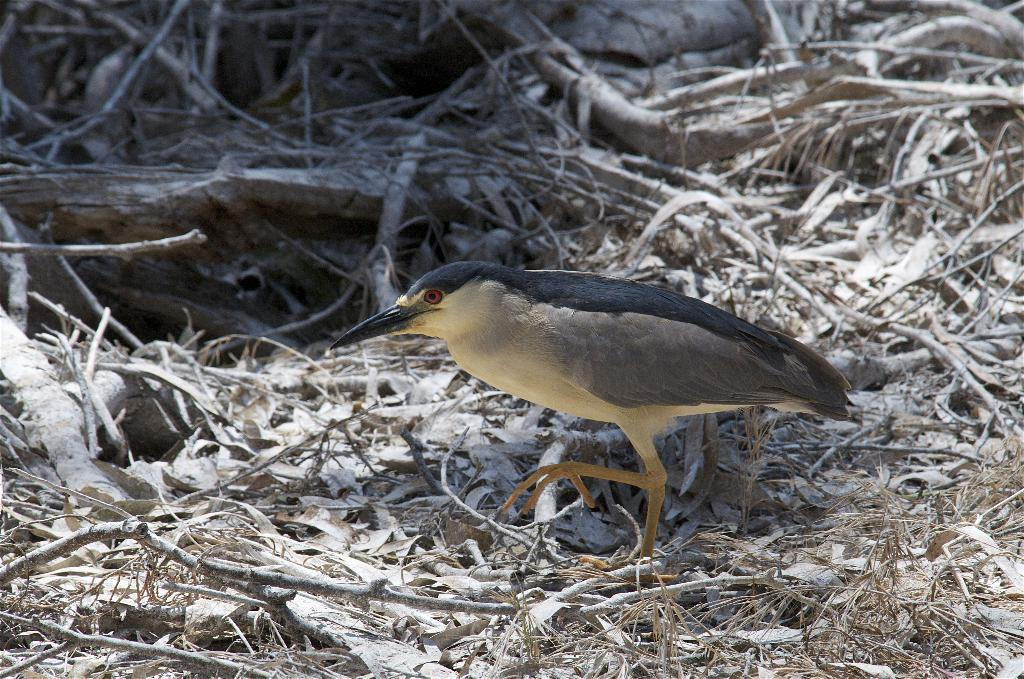What type of animal can be seen in the image? There is a bird in the image. What is the bird doing in the image? The bird is walking on the ground. What else can be seen on the ground in the image? There are sticks and dried leaves on the ground. How many rings of wax are present in the image? There is no wax or rings visible in the image. 